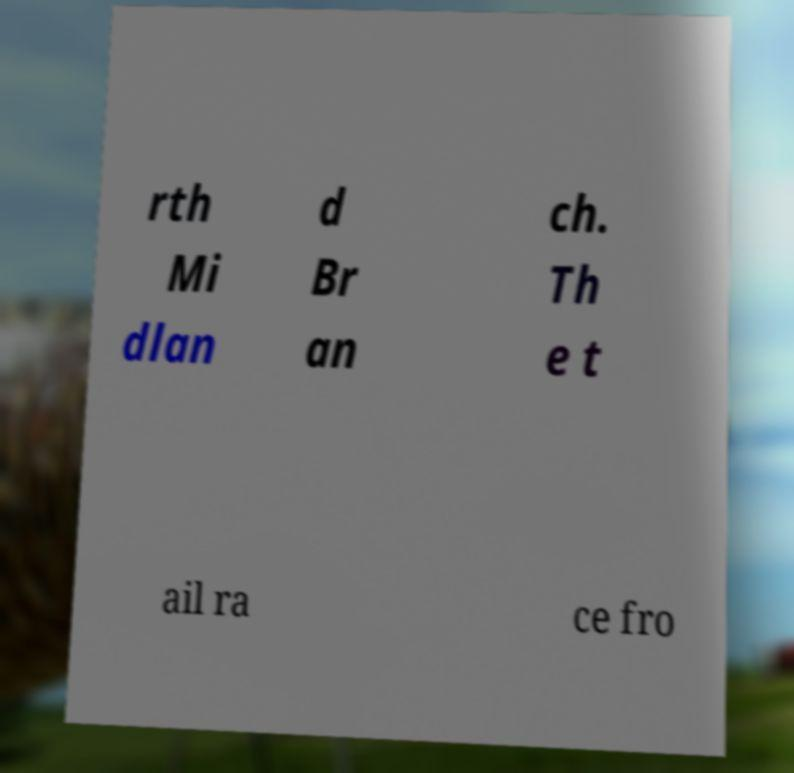Can you accurately transcribe the text from the provided image for me? rth Mi dlan d Br an ch. Th e t ail ra ce fro 